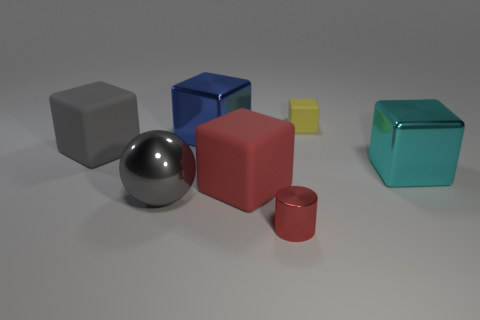The metallic object that is behind the big red thing and on the left side of the yellow thing is what color?
Your answer should be compact. Blue. Is there another tiny shiny cylinder that has the same color as the small shiny cylinder?
Provide a succinct answer. No. What color is the small thing that is on the left side of the yellow block?
Ensure brevity in your answer.  Red. Is there a tiny red cylinder right of the big metallic cube that is right of the red block?
Make the answer very short. No. There is a tiny rubber object; does it have the same color as the large metallic cube on the right side of the tiny red metallic thing?
Offer a terse response. No. Are there any spheres that have the same material as the red cylinder?
Make the answer very short. Yes. How many big blue matte spheres are there?
Make the answer very short. 0. What is the material of the tiny thing that is in front of the large metal cube that is on the left side of the small yellow block?
Your answer should be compact. Metal. There is another large block that is the same material as the big blue cube; what is its color?
Keep it short and to the point. Cyan. The rubber thing that is the same color as the ball is what shape?
Provide a succinct answer. Cube. 